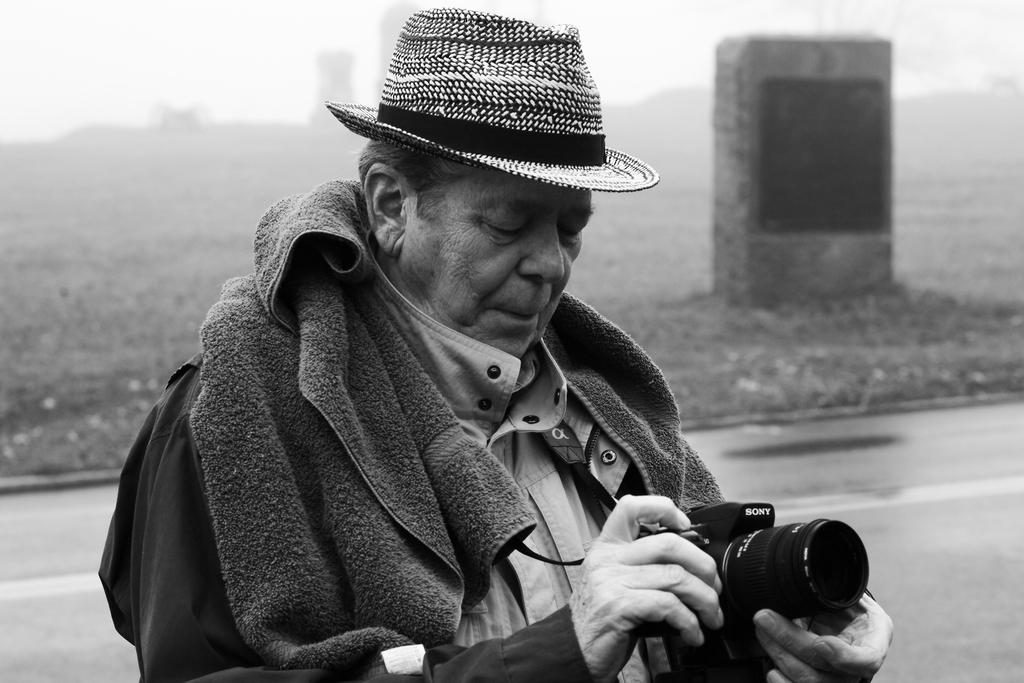What is the main subject of the picture? The main subject of the picture is a man. Can you describe the man's attire? The man is wearing a cap and has a towel around his neck. What is the man holding in his hand? The man is holding a camera in his hand. What is the man doing with the camera? The man is looking at the camera. What can be seen in the background of the picture? There are stone structures, land, buildings, smoke, and a road visible in the background. How many birds are flying over the man's head in the image? There are no birds visible in the image. What type of trucks can be seen driving on the road in the background? There are no trucks visible in the image; only a road can be seen in the background. 